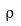<formula> <loc_0><loc_0><loc_500><loc_500>\hat { \rho }</formula> 